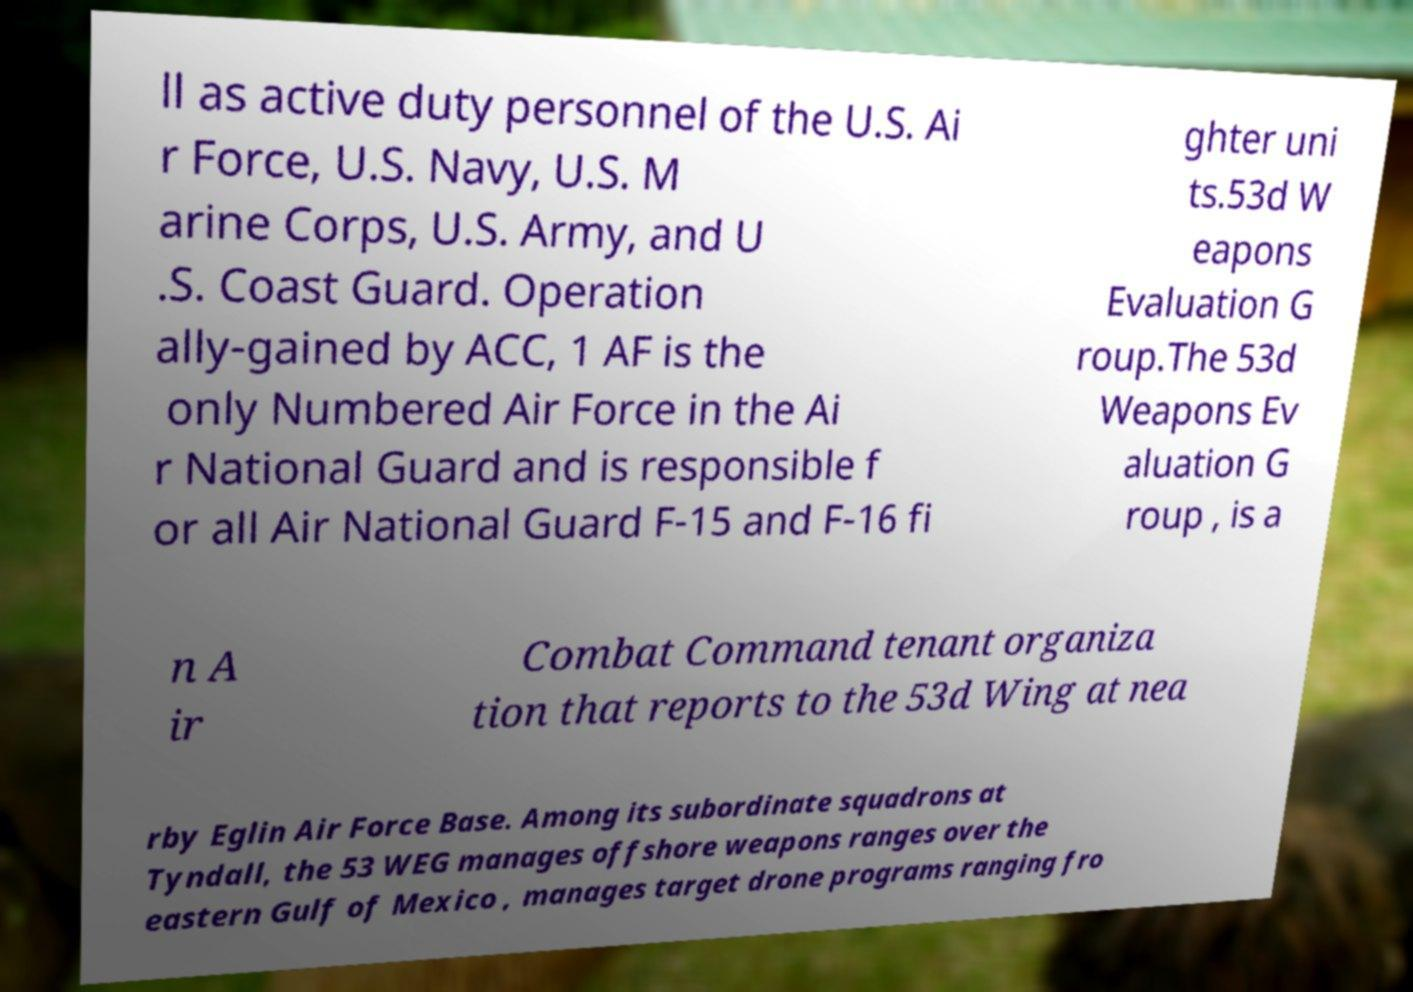Can you read and provide the text displayed in the image?This photo seems to have some interesting text. Can you extract and type it out for me? ll as active duty personnel of the U.S. Ai r Force, U.S. Navy, U.S. M arine Corps, U.S. Army, and U .S. Coast Guard. Operation ally-gained by ACC, 1 AF is the only Numbered Air Force in the Ai r National Guard and is responsible f or all Air National Guard F-15 and F-16 fi ghter uni ts.53d W eapons Evaluation G roup.The 53d Weapons Ev aluation G roup , is a n A ir Combat Command tenant organiza tion that reports to the 53d Wing at nea rby Eglin Air Force Base. Among its subordinate squadrons at Tyndall, the 53 WEG manages offshore weapons ranges over the eastern Gulf of Mexico , manages target drone programs ranging fro 